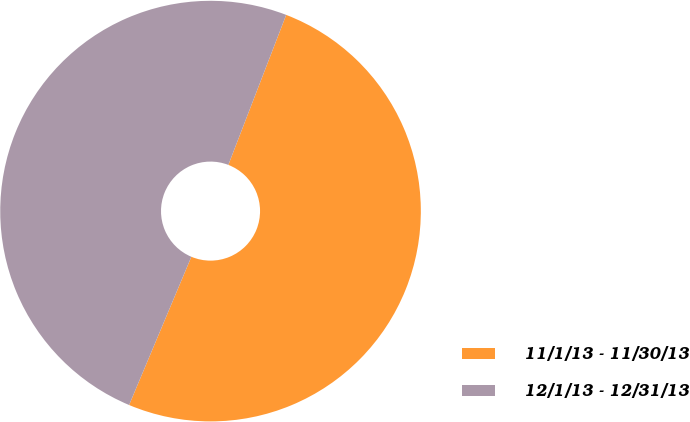Convert chart. <chart><loc_0><loc_0><loc_500><loc_500><pie_chart><fcel>11/1/13 - 11/30/13<fcel>12/1/13 - 12/31/13<nl><fcel>50.47%<fcel>49.53%<nl></chart> 